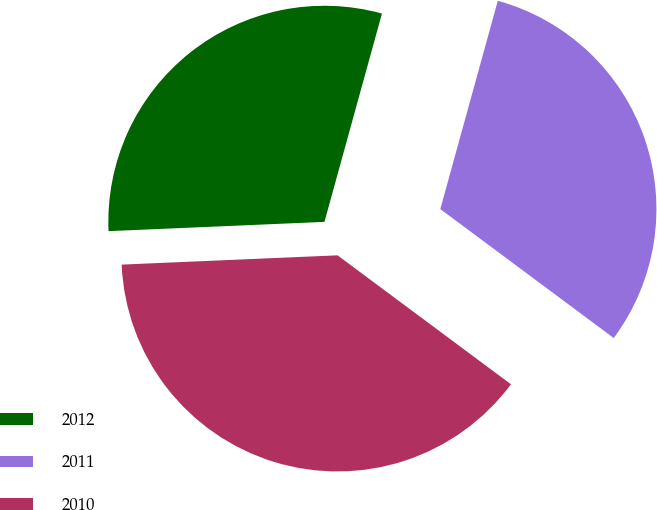Convert chart to OTSL. <chart><loc_0><loc_0><loc_500><loc_500><pie_chart><fcel>2012<fcel>2011<fcel>2010<nl><fcel>29.97%<fcel>30.89%<fcel>39.14%<nl></chart> 